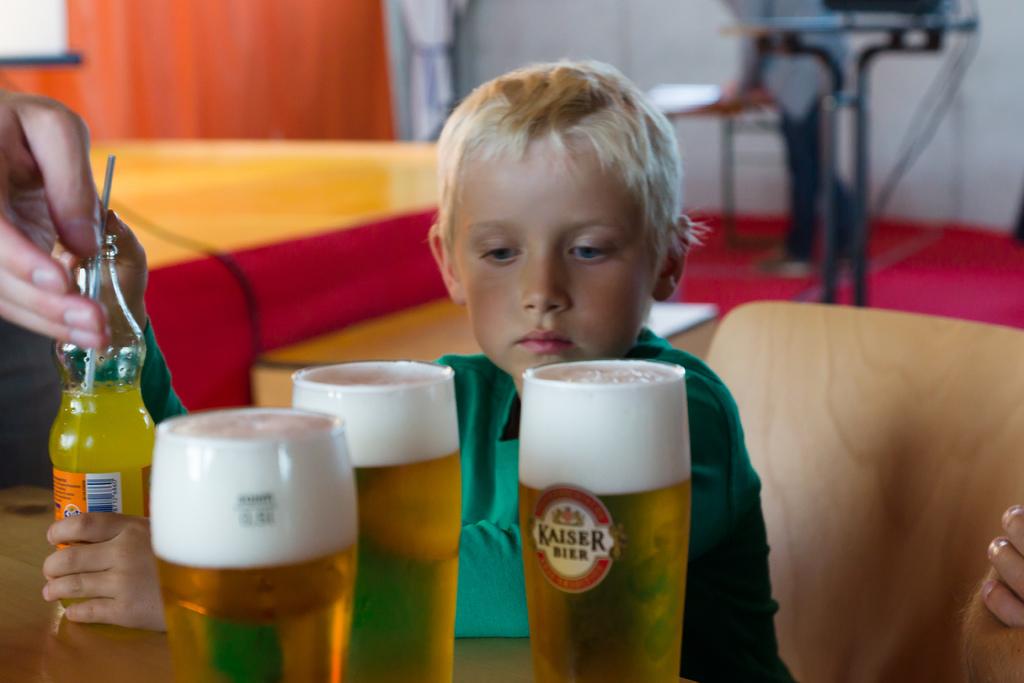What brand of beer is on the table?
Offer a terse response. Kaiser. Does that beer glass have a kaiser beer label on it?
Provide a short and direct response. Yes. 